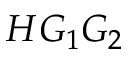<formula> <loc_0><loc_0><loc_500><loc_500>H G _ { 1 } G _ { 2 }</formula> 